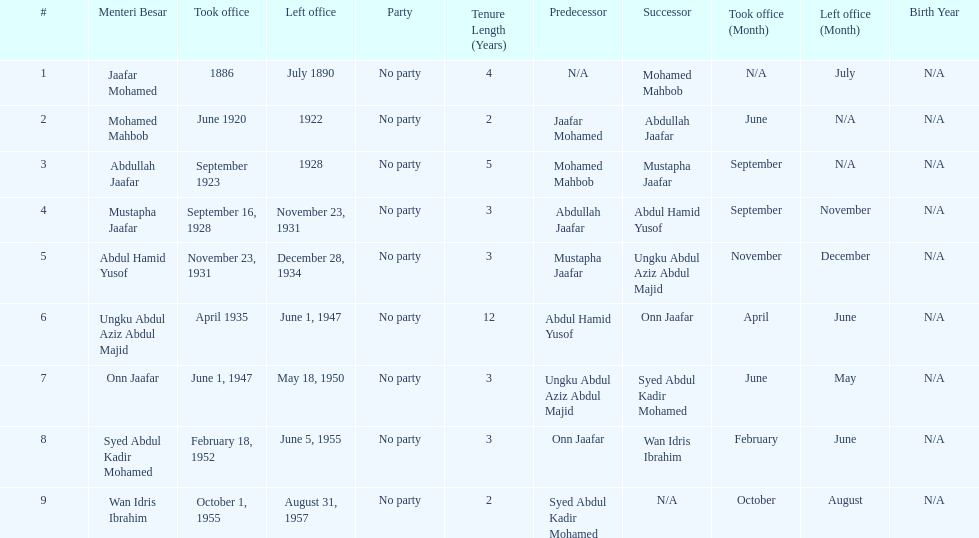Who spend the most amount of time in office? Ungku Abdul Aziz Abdul Majid. 